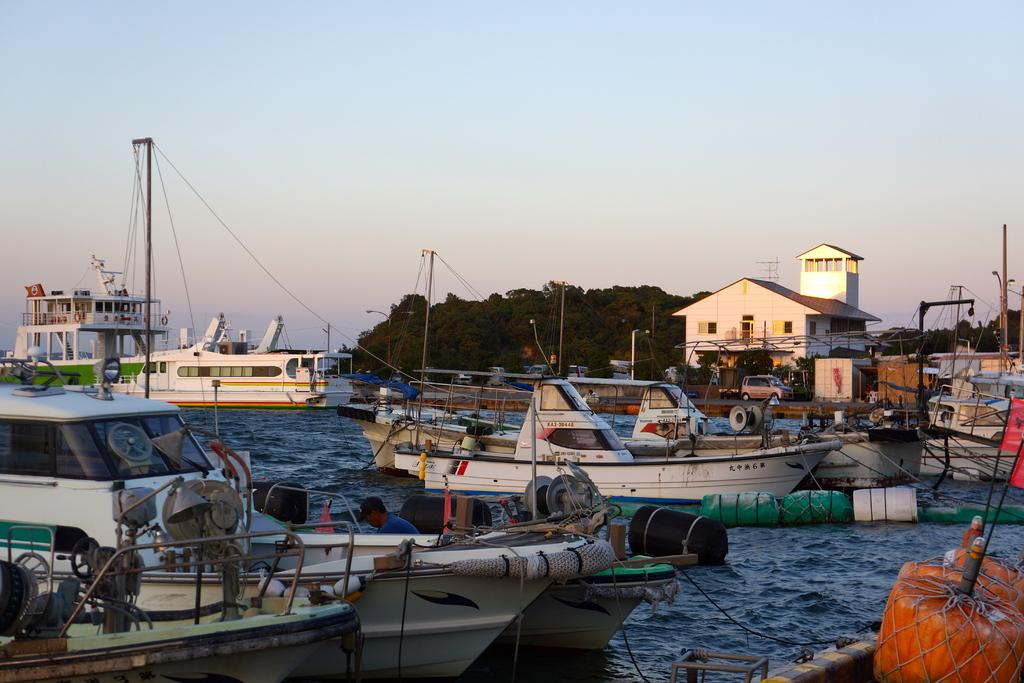What is the location of the image? The image is taken near a shipping harbor. What can be seen in the foreground of the image? There are boats in the foreground of the image. What other elements are present in the image? There are trees, vehicles, and buildings in the center of the image. Is there a volcano erupting in the background of the image? No, there is no volcano present in the image. Can you see a cannon being fired in the image? No, there is no cannon or any indication of a cannon being fired in the image. 